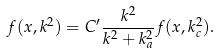Convert formula to latex. <formula><loc_0><loc_0><loc_500><loc_500>f ( x , k ^ { 2 } ) = C ^ { \prime } \frac { k ^ { 2 } } { k ^ { 2 } + k _ { a } ^ { 2 } } f ( x , k _ { c } ^ { 2 } ) .</formula> 